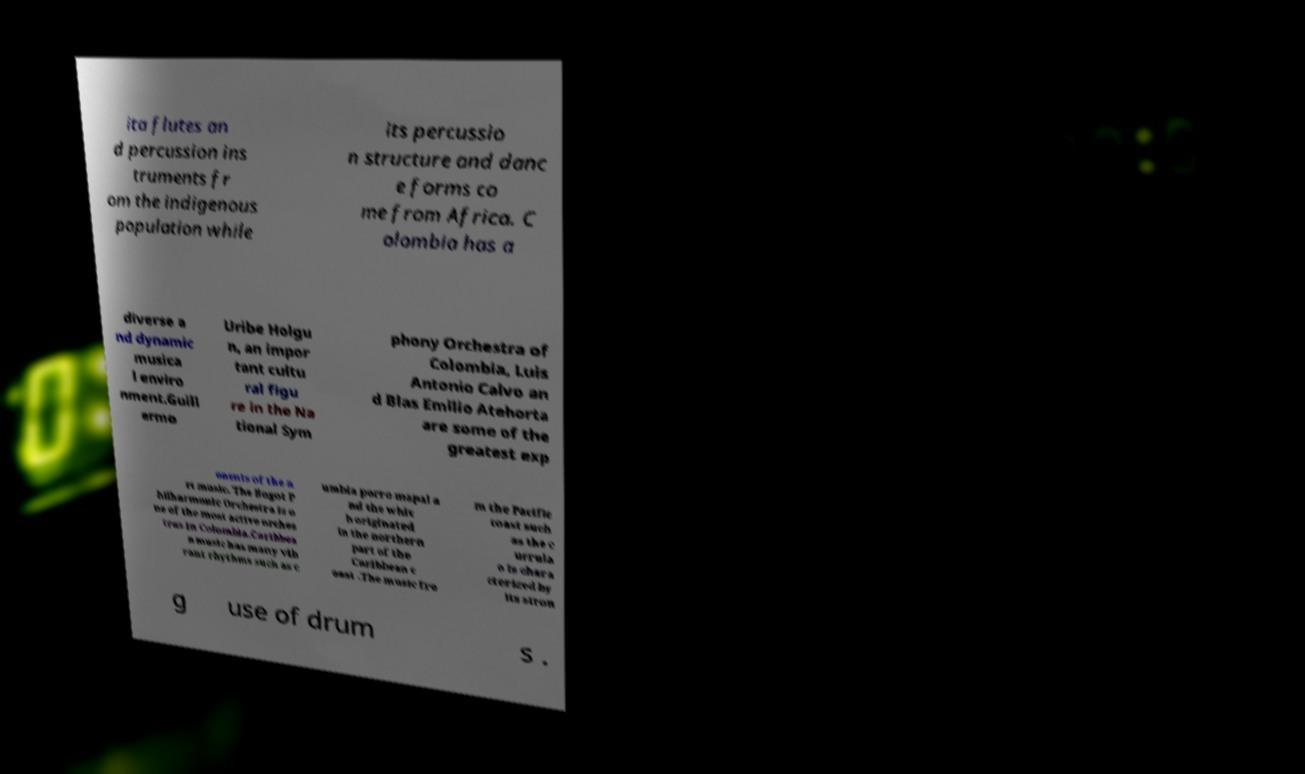There's text embedded in this image that I need extracted. Can you transcribe it verbatim? ita flutes an d percussion ins truments fr om the indigenous population while its percussio n structure and danc e forms co me from Africa. C olombia has a diverse a nd dynamic musica l enviro nment.Guill ermo Uribe Holgu n, an impor tant cultu ral figu re in the Na tional Sym phony Orchestra of Colombia, Luis Antonio Calvo an d Blas Emilio Atehorta are some of the greatest exp onents of the a rt music. The Bogot P hilharmonic Orchestra is o ne of the most active orches tras in Colombia.Caribbea n music has many vib rant rhythms such as c umbia porro mapal a nd the whic h originated in the northern part of the Caribbean c oast .The music fro m the Pacific coast such as the c urrula o is chara cterized by its stron g use of drum s . 